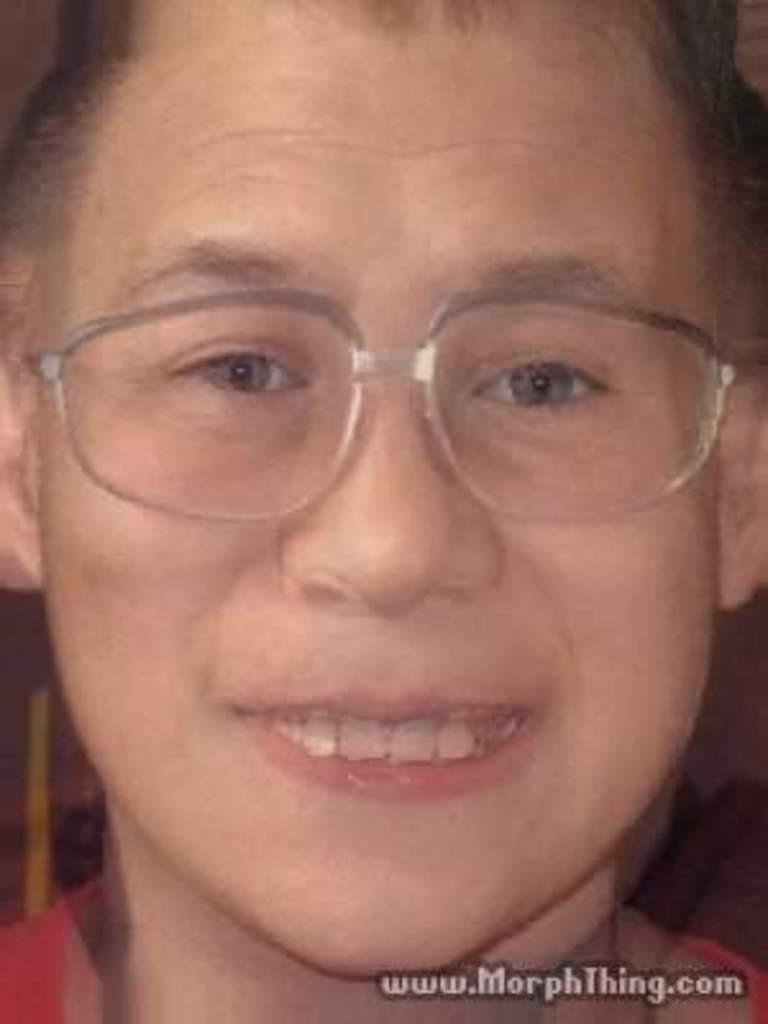What is the main subject of the image? There is a person in the image. Can you describe any text present in the image? There is some text in the bottom right corner of the image. Can you tell me how many toads are visible in the image? There are no toads present in the image. What type of tank is visible in the image? There is no tank present in the image. 